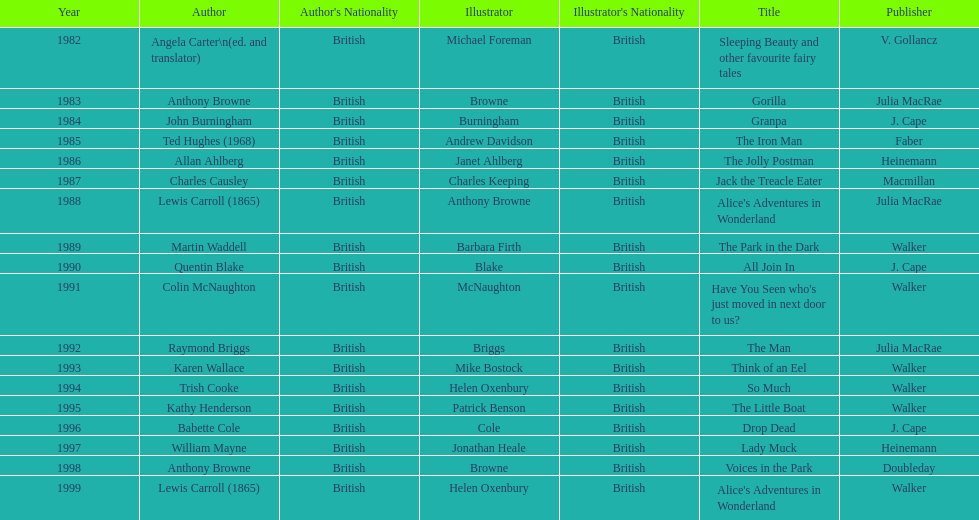Which book won the award a total of 2 times? Alice's Adventures in Wonderland. 